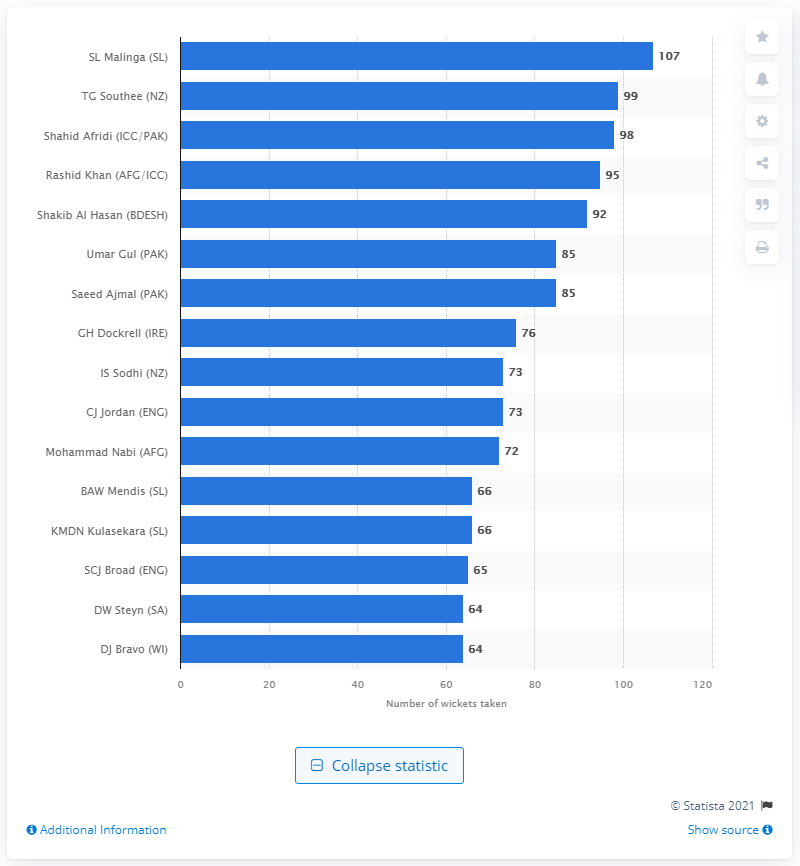List a handful of essential elements in this visual. Lasith Malinga took 107 wickets in his career, a remarkable achievement for a fast bowler. 